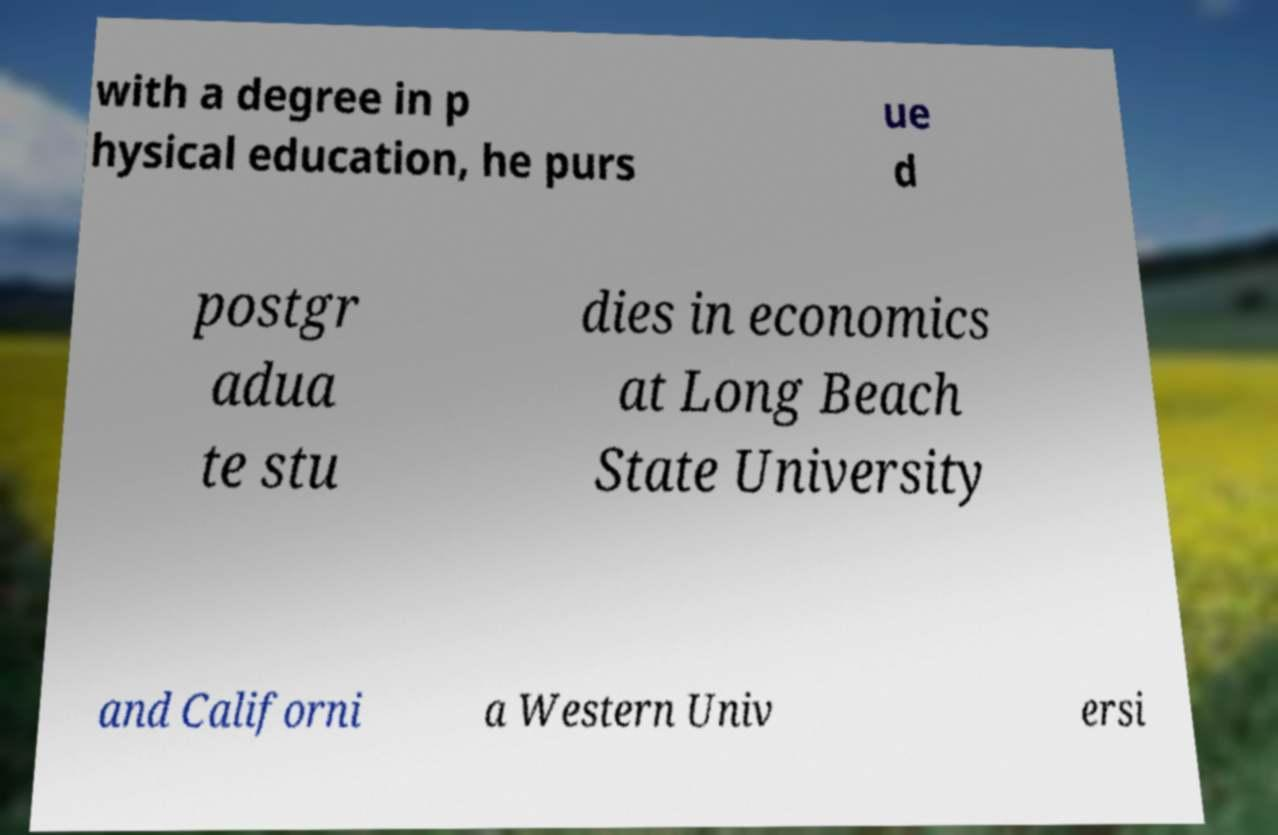There's text embedded in this image that I need extracted. Can you transcribe it verbatim? with a degree in p hysical education, he purs ue d postgr adua te stu dies in economics at Long Beach State University and Californi a Western Univ ersi 